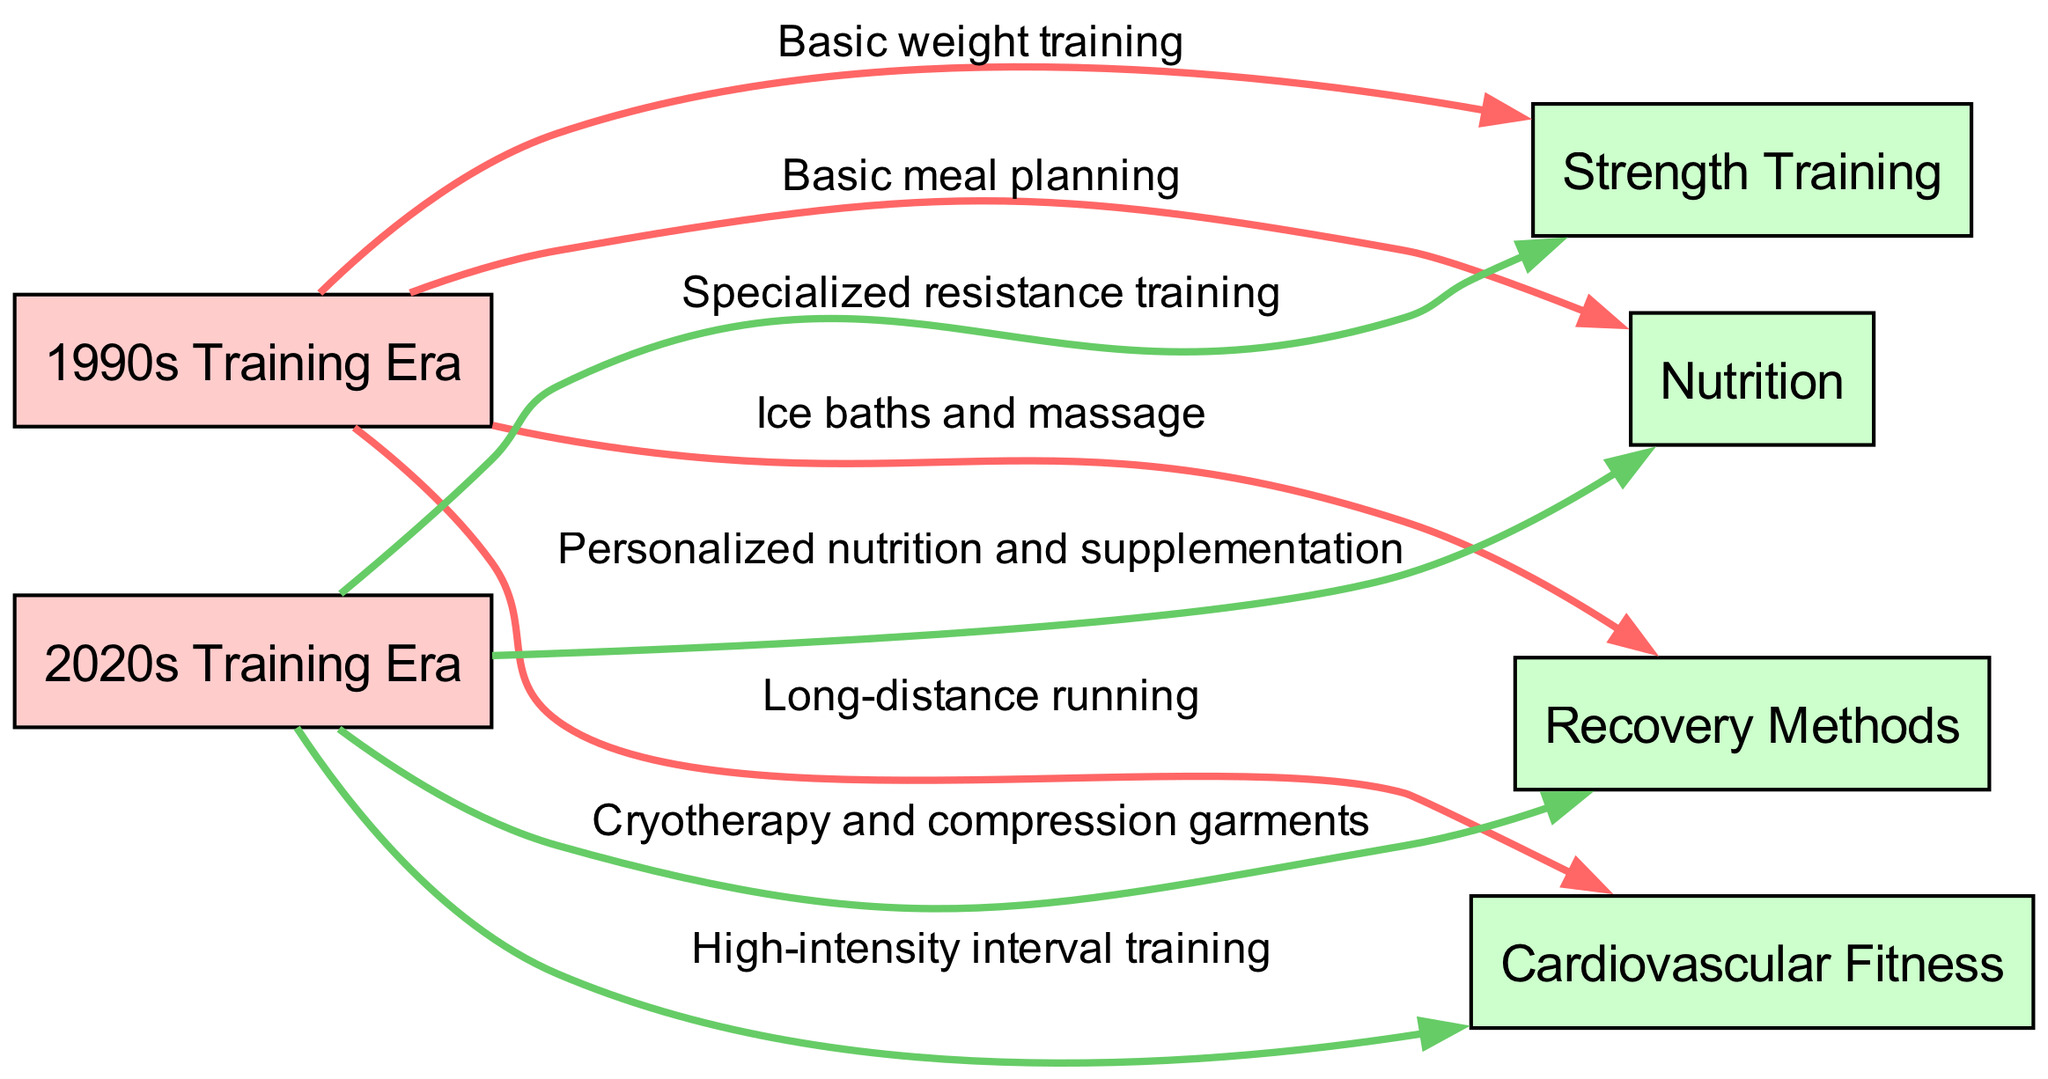What training method is associated with the 1990s era for strength? The diagram indicates that the training method for strength in the 1990s era is labeled "Basic weight training." This can be found by following the edge from the "1990s Training Era" node to the "Strength Training" node and reading the label on that edge.
Answer: Basic weight training How many recovery methods are listed in the diagram? The diagram includes two distinct recovery methods: "Ice baths and massage" for the 1990s and "Cryotherapy and compression garments" for the 2020s. Counting these methods provides the answer.
Answer: 2 What is the primary focus of cardio training in the 2020s? According to the diagram, the cardio training method for the 2020s is "High-intensity interval training." This can be confirmed by checking the edge leading from the "2020s Training Era" to the "Cardiovascular Fitness" node.
Answer: High-intensity interval training Which era shows a more sophisticated approach to nutrition? The 2020s era presents a more sophisticated approach to nutrition with "Personalized nutrition and supplementation," whereas the 1990s is described as "Basic meal planning." By comparing these labels, the 2020s clearly has a more advanced method.
Answer: 2020s What type of strength training method was used in the 1990s compared to the 2020s? The diagram distinguishes between the two methods by showing that the 1990s used "Basic weight training," whereas the 2020s employed "Specialized resistance training." This comparison can be made by analyzing the labels associated with each era's strength training node.
Answer: Basic weight training, Specialized resistance training What does the edge label from the 1990s to recovery indicate? The edge from the "1990s Training Era" to the "Recovery Methods" node indicates the recovery methods of "Ice baths and massage." This information is directly labeled on the edge itself, providing a straightforward answer.
Answer: Ice baths and massage Which nodes represent training methods in the 2020s? The nodes representing training methods in the 2020s are "Strength Training," "Cardiovascular Fitness," "Recovery Methods," and "Nutrition." By checking the respective edges leading from the "2020s Training Era" node, all these methods can be identified.
Answer: Strength Training, Cardiovascular Fitness, Recovery Methods, Nutrition What is a characteristic of recovery methods in the 2020s compared to the 1990s? The recovery methods for the 2020s include "Cryotherapy and compression garments," which are more modern and sophisticated compared to the "Ice baths and massage" used in the 1990s. This contrasts the two eras, highlighting advancements in recovery techniques.
Answer: Cryotherapy and compression garments 